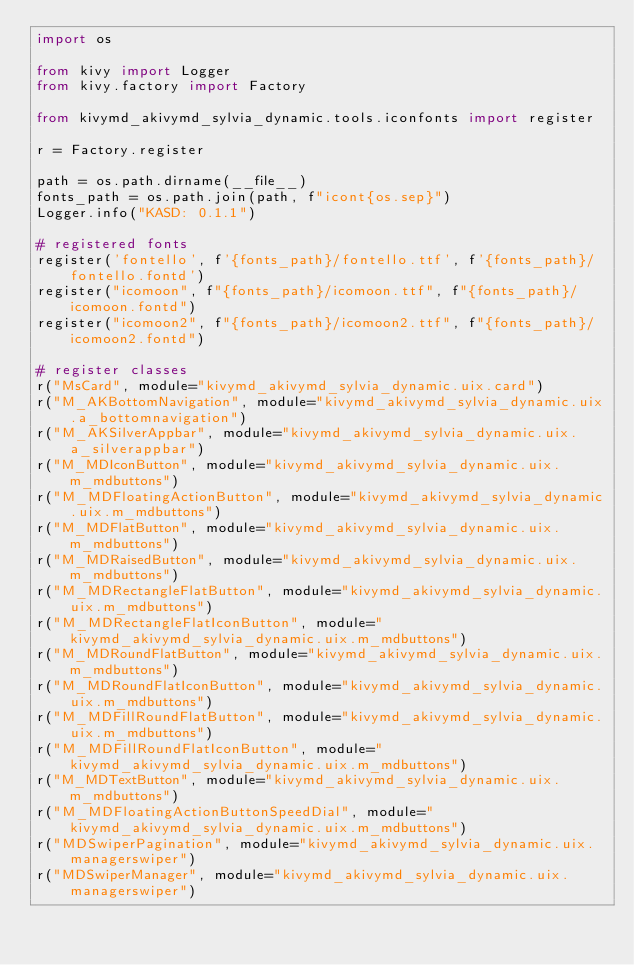Convert code to text. <code><loc_0><loc_0><loc_500><loc_500><_Python_>import os

from kivy import Logger
from kivy.factory import Factory

from kivymd_akivymd_sylvia_dynamic.tools.iconfonts import register

r = Factory.register

path = os.path.dirname(__file__)
fonts_path = os.path.join(path, f"icont{os.sep}")
Logger.info("KASD: 0.1.1")

# registered fonts
register('fontello', f'{fonts_path}/fontello.ttf', f'{fonts_path}/fontello.fontd')
register("icomoon", f"{fonts_path}/icomoon.ttf", f"{fonts_path}/icomoon.fontd")
register("icomoon2", f"{fonts_path}/icomoon2.ttf", f"{fonts_path}/icomoon2.fontd")

# register classes
r("MsCard", module="kivymd_akivymd_sylvia_dynamic.uix.card")
r("M_AKBottomNavigation", module="kivymd_akivymd_sylvia_dynamic.uix.a_bottomnavigation")
r("M_AKSilverAppbar", module="kivymd_akivymd_sylvia_dynamic.uix.a_silverappbar")
r("M_MDIconButton", module="kivymd_akivymd_sylvia_dynamic.uix.m_mdbuttons")
r("M_MDFloatingActionButton", module="kivymd_akivymd_sylvia_dynamic.uix.m_mdbuttons")
r("M_MDFlatButton", module="kivymd_akivymd_sylvia_dynamic.uix.m_mdbuttons")
r("M_MDRaisedButton", module="kivymd_akivymd_sylvia_dynamic.uix.m_mdbuttons")
r("M_MDRectangleFlatButton", module="kivymd_akivymd_sylvia_dynamic.uix.m_mdbuttons")
r("M_MDRectangleFlatIconButton", module="kivymd_akivymd_sylvia_dynamic.uix.m_mdbuttons")
r("M_MDRoundFlatButton", module="kivymd_akivymd_sylvia_dynamic.uix.m_mdbuttons")
r("M_MDRoundFlatIconButton", module="kivymd_akivymd_sylvia_dynamic.uix.m_mdbuttons")
r("M_MDFillRoundFlatButton", module="kivymd_akivymd_sylvia_dynamic.uix.m_mdbuttons")
r("M_MDFillRoundFlatIconButton", module="kivymd_akivymd_sylvia_dynamic.uix.m_mdbuttons")
r("M_MDTextButton", module="kivymd_akivymd_sylvia_dynamic.uix.m_mdbuttons")
r("M_MDFloatingActionButtonSpeedDial", module="kivymd_akivymd_sylvia_dynamic.uix.m_mdbuttons")
r("MDSwiperPagination", module="kivymd_akivymd_sylvia_dynamic.uix.managerswiper")
r("MDSwiperManager", module="kivymd_akivymd_sylvia_dynamic.uix.managerswiper")
</code> 